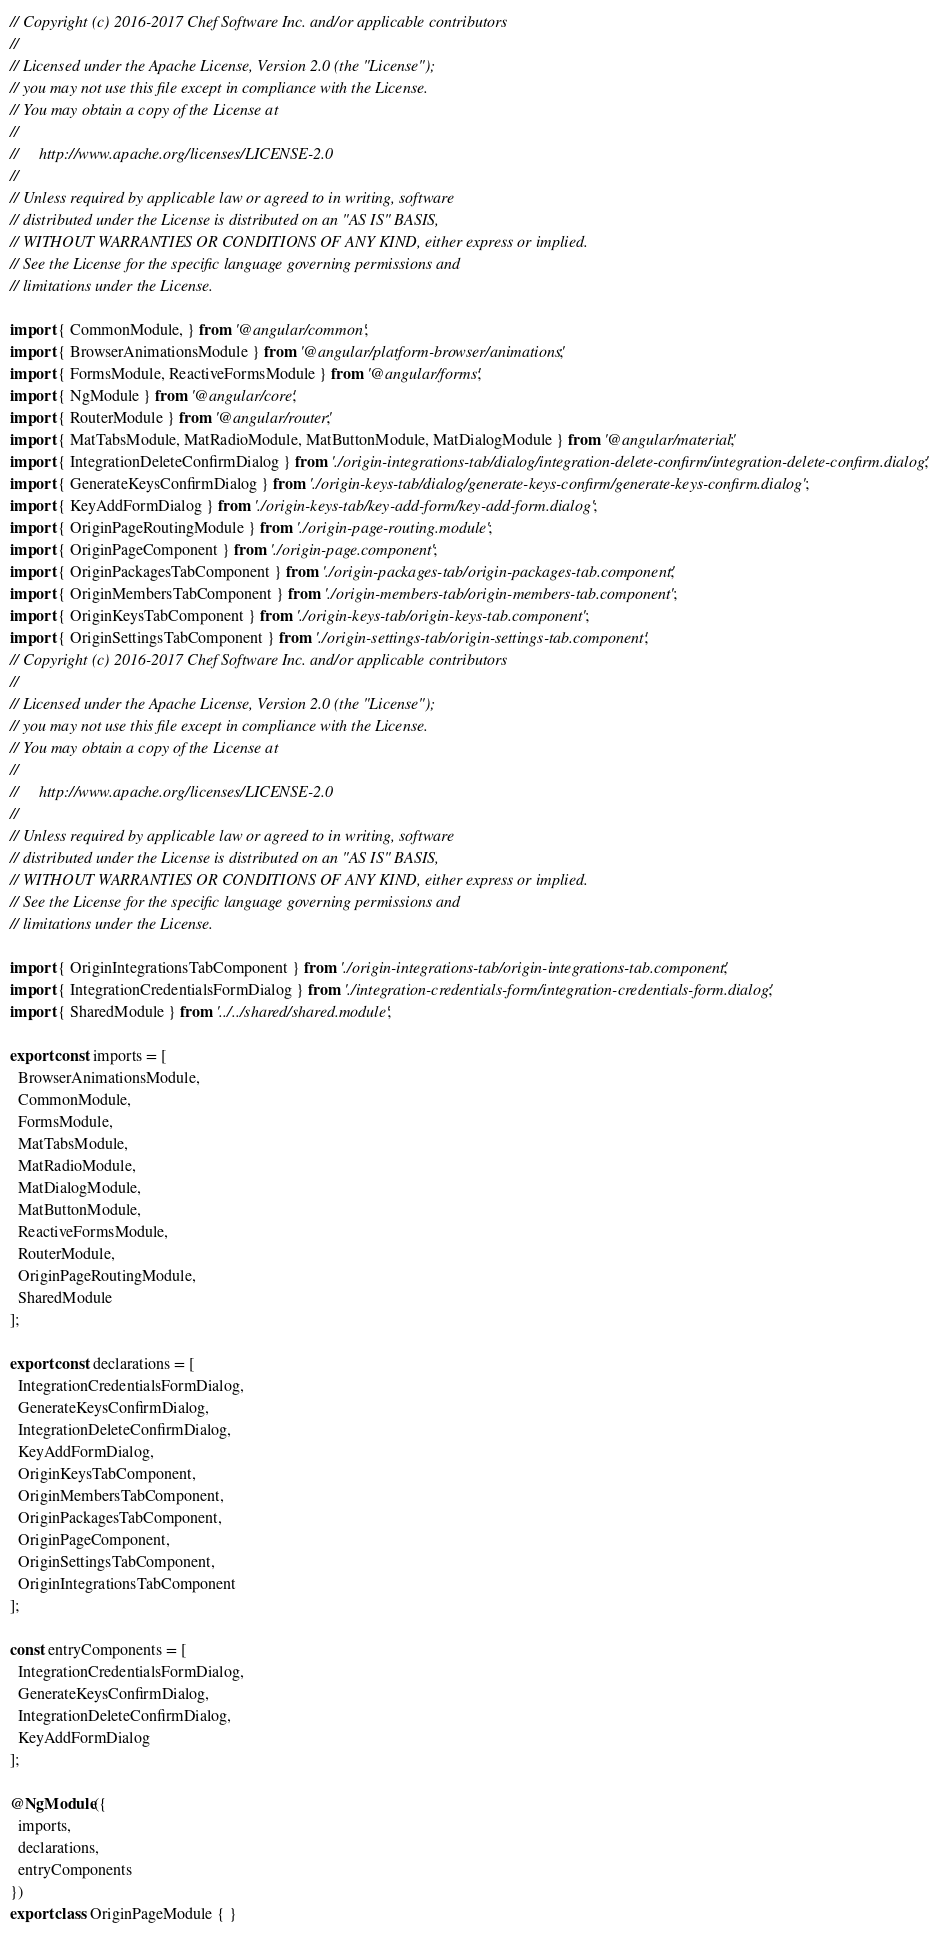Convert code to text. <code><loc_0><loc_0><loc_500><loc_500><_TypeScript_>// Copyright (c) 2016-2017 Chef Software Inc. and/or applicable contributors
//
// Licensed under the Apache License, Version 2.0 (the "License");
// you may not use this file except in compliance with the License.
// You may obtain a copy of the License at
//
//     http://www.apache.org/licenses/LICENSE-2.0
//
// Unless required by applicable law or agreed to in writing, software
// distributed under the License is distributed on an "AS IS" BASIS,
// WITHOUT WARRANTIES OR CONDITIONS OF ANY KIND, either express or implied.
// See the License for the specific language governing permissions and
// limitations under the License.

import { CommonModule, } from '@angular/common';
import { BrowserAnimationsModule } from '@angular/platform-browser/animations';
import { FormsModule, ReactiveFormsModule } from '@angular/forms';
import { NgModule } from '@angular/core';
import { RouterModule } from '@angular/router';
import { MatTabsModule, MatRadioModule, MatButtonModule, MatDialogModule } from '@angular/material';
import { IntegrationDeleteConfirmDialog } from './origin-integrations-tab/dialog/integration-delete-confirm/integration-delete-confirm.dialog';
import { GenerateKeysConfirmDialog } from './origin-keys-tab/dialog/generate-keys-confirm/generate-keys-confirm.dialog';
import { KeyAddFormDialog } from './origin-keys-tab/key-add-form/key-add-form.dialog';
import { OriginPageRoutingModule } from './origin-page-routing.module';
import { OriginPageComponent } from './origin-page.component';
import { OriginPackagesTabComponent } from './origin-packages-tab/origin-packages-tab.component';
import { OriginMembersTabComponent } from './origin-members-tab/origin-members-tab.component';
import { OriginKeysTabComponent } from './origin-keys-tab/origin-keys-tab.component';
import { OriginSettingsTabComponent } from './origin-settings-tab/origin-settings-tab.component';
// Copyright (c) 2016-2017 Chef Software Inc. and/or applicable contributors
//
// Licensed under the Apache License, Version 2.0 (the "License");
// you may not use this file except in compliance with the License.
// You may obtain a copy of the License at
//
//     http://www.apache.org/licenses/LICENSE-2.0
//
// Unless required by applicable law or agreed to in writing, software
// distributed under the License is distributed on an "AS IS" BASIS,
// WITHOUT WARRANTIES OR CONDITIONS OF ANY KIND, either express or implied.
// See the License for the specific language governing permissions and
// limitations under the License.

import { OriginIntegrationsTabComponent } from './origin-integrations-tab/origin-integrations-tab.component';
import { IntegrationCredentialsFormDialog } from './integration-credentials-form/integration-credentials-form.dialog';
import { SharedModule } from '../../shared/shared.module';

export const imports = [
  BrowserAnimationsModule,
  CommonModule,
  FormsModule,
  MatTabsModule,
  MatRadioModule,
  MatDialogModule,
  MatButtonModule,
  ReactiveFormsModule,
  RouterModule,
  OriginPageRoutingModule,
  SharedModule
];

export const declarations = [
  IntegrationCredentialsFormDialog,
  GenerateKeysConfirmDialog,
  IntegrationDeleteConfirmDialog,
  KeyAddFormDialog,
  OriginKeysTabComponent,
  OriginMembersTabComponent,
  OriginPackagesTabComponent,
  OriginPageComponent,
  OriginSettingsTabComponent,
  OriginIntegrationsTabComponent
];

const entryComponents = [
  IntegrationCredentialsFormDialog,
  GenerateKeysConfirmDialog,
  IntegrationDeleteConfirmDialog,
  KeyAddFormDialog
];

@NgModule({
  imports,
  declarations,
  entryComponents
})
export class OriginPageModule { }
</code> 